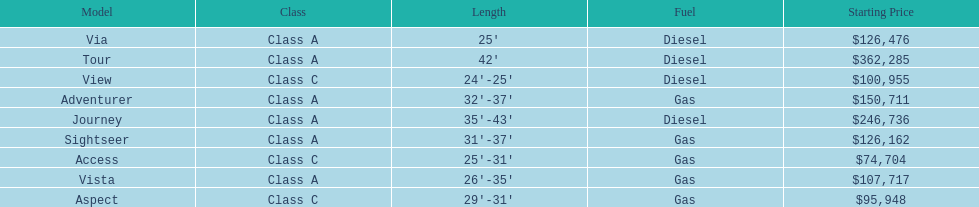What is the total number of class a models? 6. 